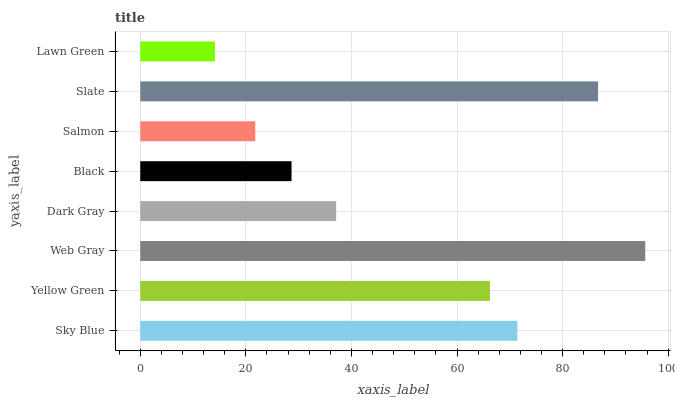Is Lawn Green the minimum?
Answer yes or no. Yes. Is Web Gray the maximum?
Answer yes or no. Yes. Is Yellow Green the minimum?
Answer yes or no. No. Is Yellow Green the maximum?
Answer yes or no. No. Is Sky Blue greater than Yellow Green?
Answer yes or no. Yes. Is Yellow Green less than Sky Blue?
Answer yes or no. Yes. Is Yellow Green greater than Sky Blue?
Answer yes or no. No. Is Sky Blue less than Yellow Green?
Answer yes or no. No. Is Yellow Green the high median?
Answer yes or no. Yes. Is Dark Gray the low median?
Answer yes or no. Yes. Is Dark Gray the high median?
Answer yes or no. No. Is Yellow Green the low median?
Answer yes or no. No. 